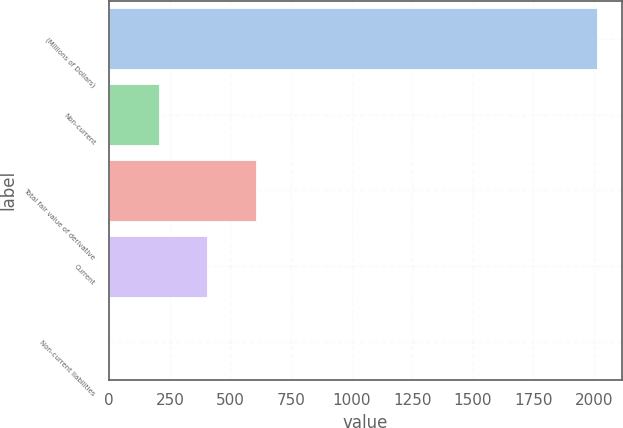Convert chart to OTSL. <chart><loc_0><loc_0><loc_500><loc_500><bar_chart><fcel>(Millions of Dollars)<fcel>Non-current<fcel>Total fair value of derivative<fcel>Current<fcel>Non-current liabilities<nl><fcel>2013<fcel>204<fcel>606<fcel>405<fcel>3<nl></chart> 